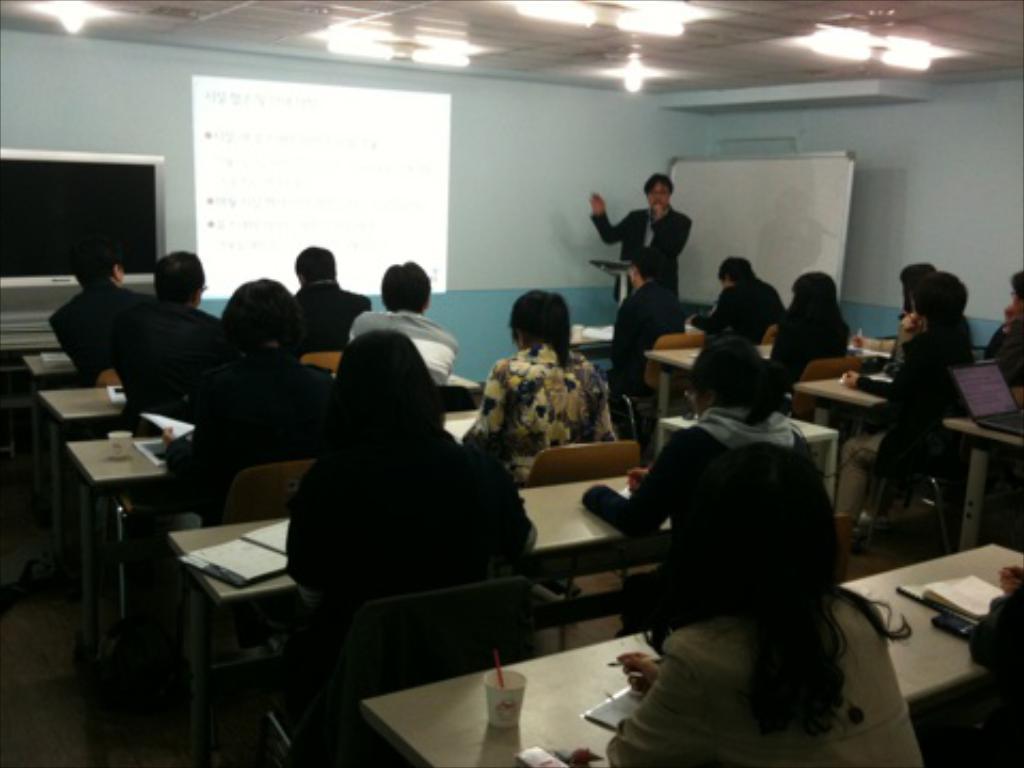Can you describe this image briefly? In this image there are group of people sitting in chair and the back ground there is man , screen , television, board , light. 